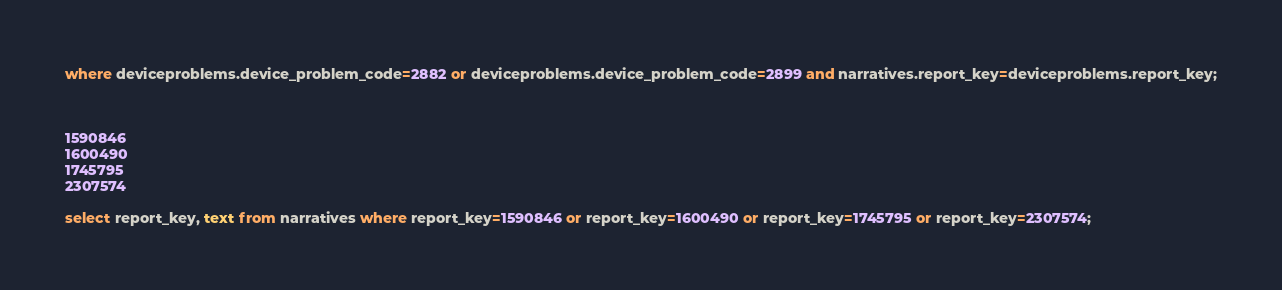Convert code to text. <code><loc_0><loc_0><loc_500><loc_500><_SQL_>where deviceproblems.device_problem_code=2882 or deviceproblems.device_problem_code=2899 and narratives.report_key=deviceproblems.report_key;



1590846
1600490
1745795
2307574

select report_key, text from narratives where report_key=1590846 or report_key=1600490 or report_key=1745795 or report_key=2307574;
</code> 